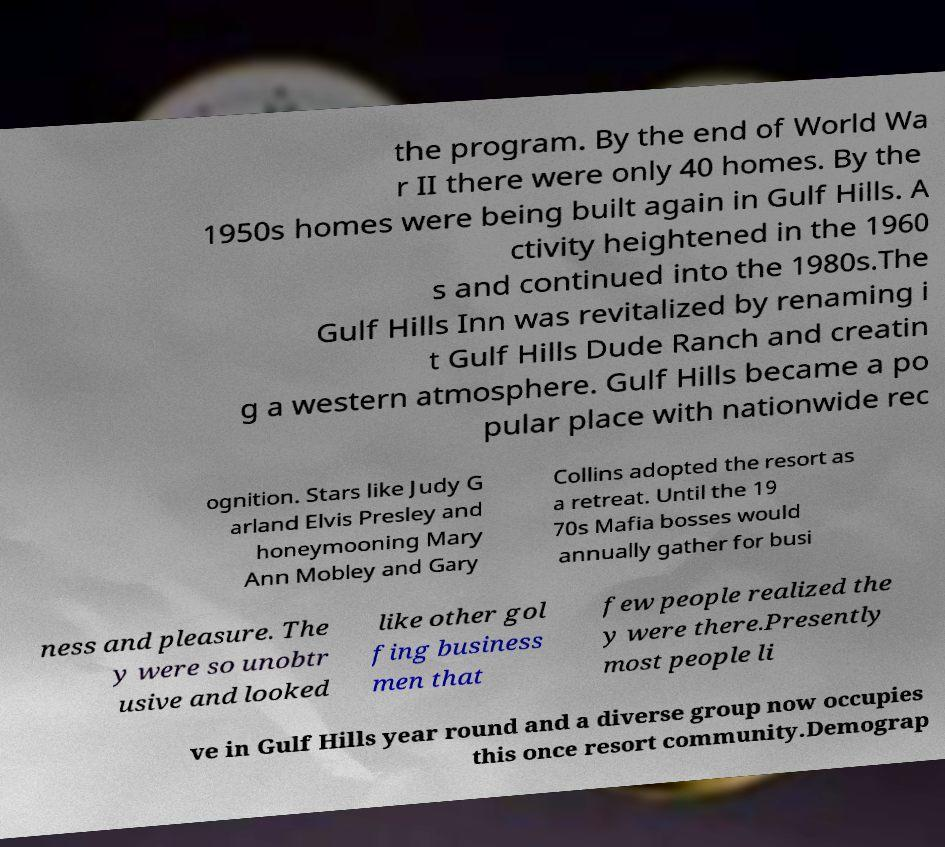Please identify and transcribe the text found in this image. the program. By the end of World Wa r II there were only 40 homes. By the 1950s homes were being built again in Gulf Hills. A ctivity heightened in the 1960 s and continued into the 1980s.The Gulf Hills Inn was revitalized by renaming i t Gulf Hills Dude Ranch and creatin g a western atmosphere. Gulf Hills became a po pular place with nationwide rec ognition. Stars like Judy G arland Elvis Presley and honeymooning Mary Ann Mobley and Gary Collins adopted the resort as a retreat. Until the 19 70s Mafia bosses would annually gather for busi ness and pleasure. The y were so unobtr usive and looked like other gol fing business men that few people realized the y were there.Presently most people li ve in Gulf Hills year round and a diverse group now occupies this once resort community.Demograp 